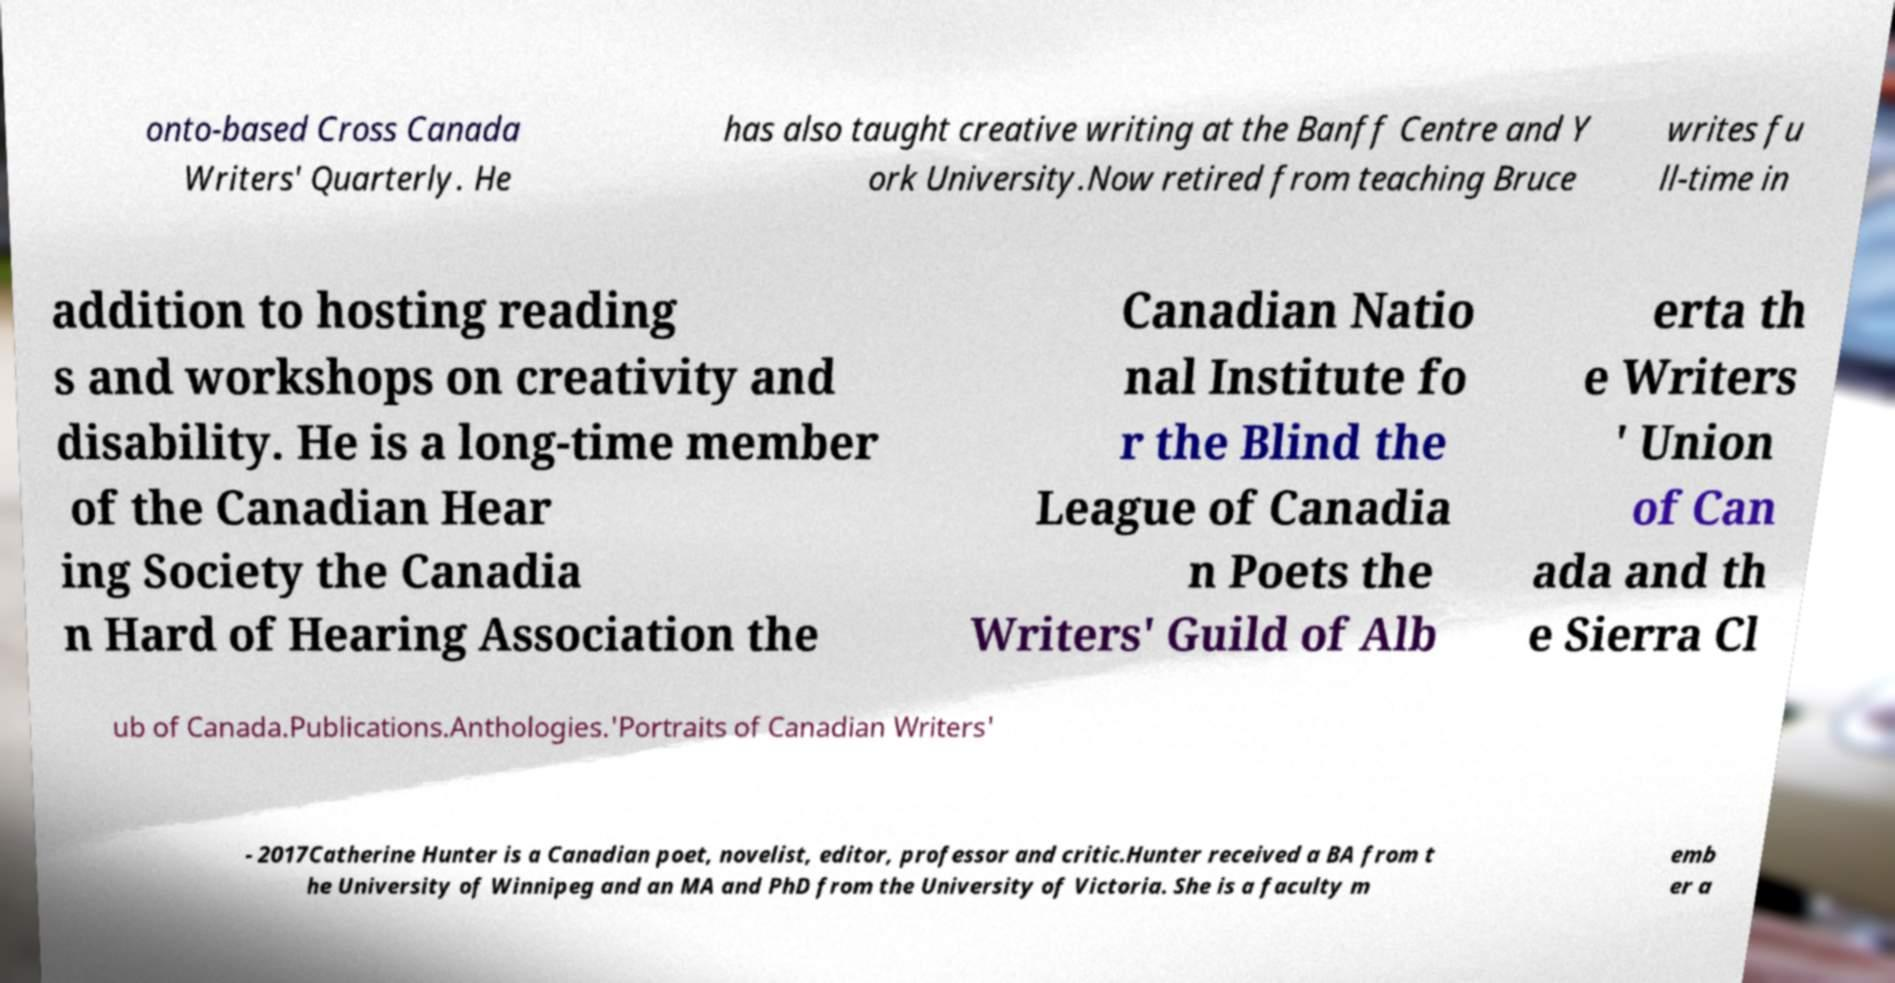I need the written content from this picture converted into text. Can you do that? onto-based Cross Canada Writers' Quarterly. He has also taught creative writing at the Banff Centre and Y ork University.Now retired from teaching Bruce writes fu ll-time in addition to hosting reading s and workshops on creativity and disability. He is a long-time member of the Canadian Hear ing Society the Canadia n Hard of Hearing Association the Canadian Natio nal Institute fo r the Blind the League of Canadia n Poets the Writers' Guild of Alb erta th e Writers ' Union of Can ada and th e Sierra Cl ub of Canada.Publications.Anthologies.'Portraits of Canadian Writers' - 2017Catherine Hunter is a Canadian poet, novelist, editor, professor and critic.Hunter received a BA from t he University of Winnipeg and an MA and PhD from the University of Victoria. She is a faculty m emb er a 